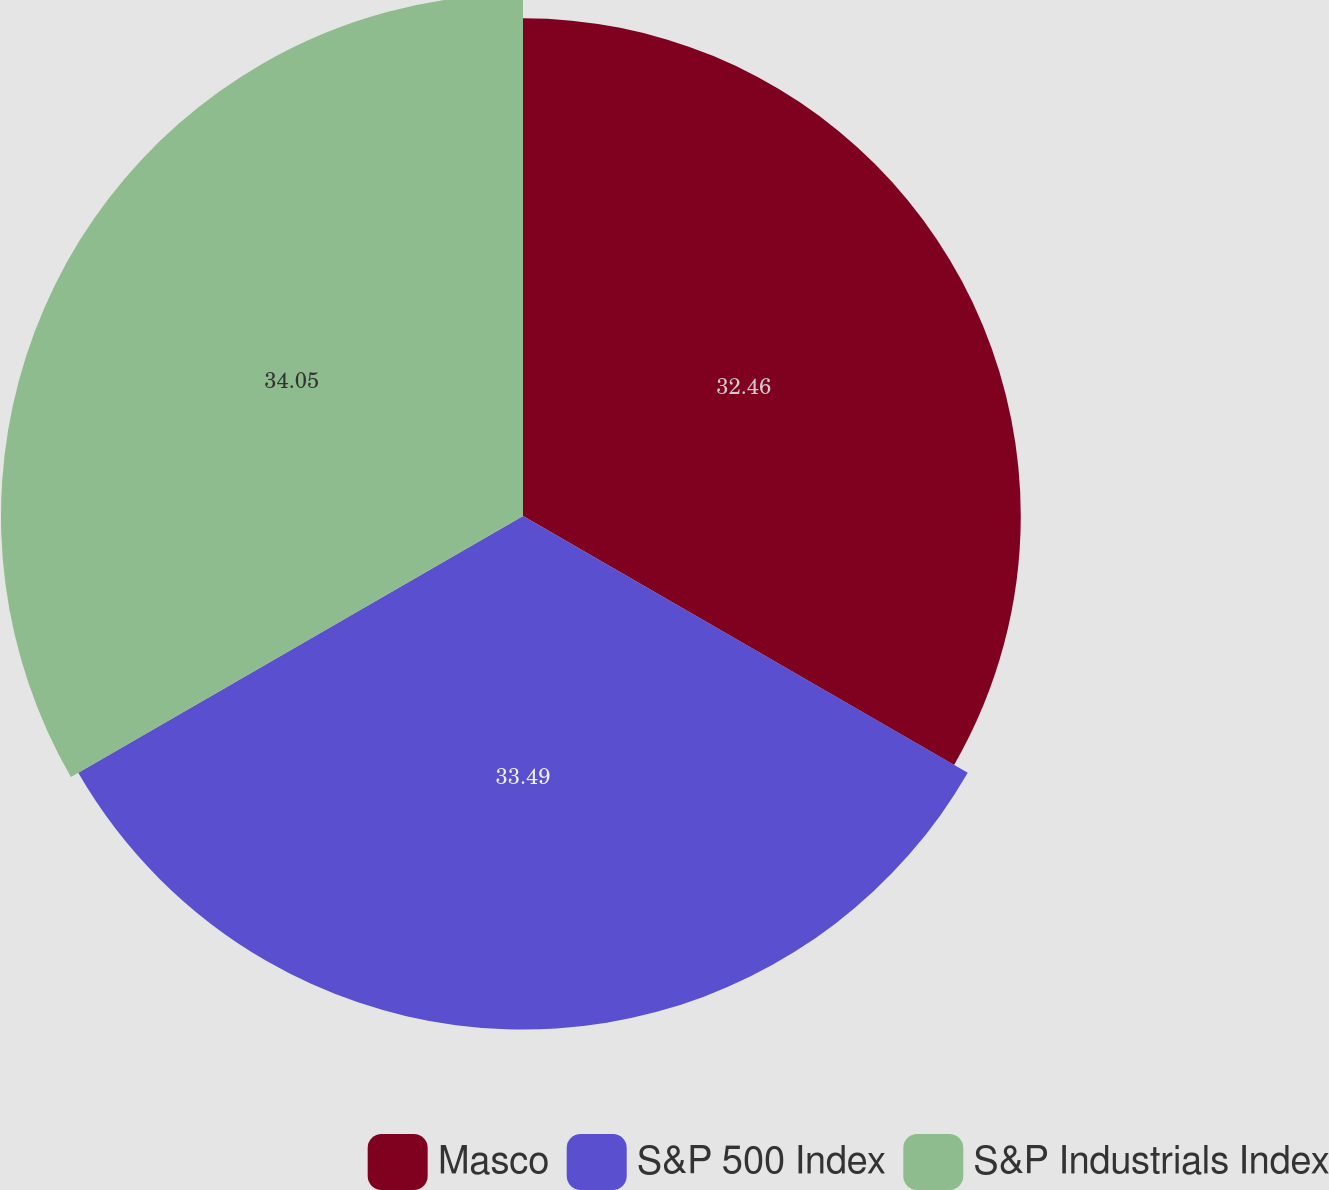Convert chart to OTSL. <chart><loc_0><loc_0><loc_500><loc_500><pie_chart><fcel>Masco<fcel>S&P 500 Index<fcel>S&P Industrials Index<nl><fcel>32.46%<fcel>33.49%<fcel>34.04%<nl></chart> 